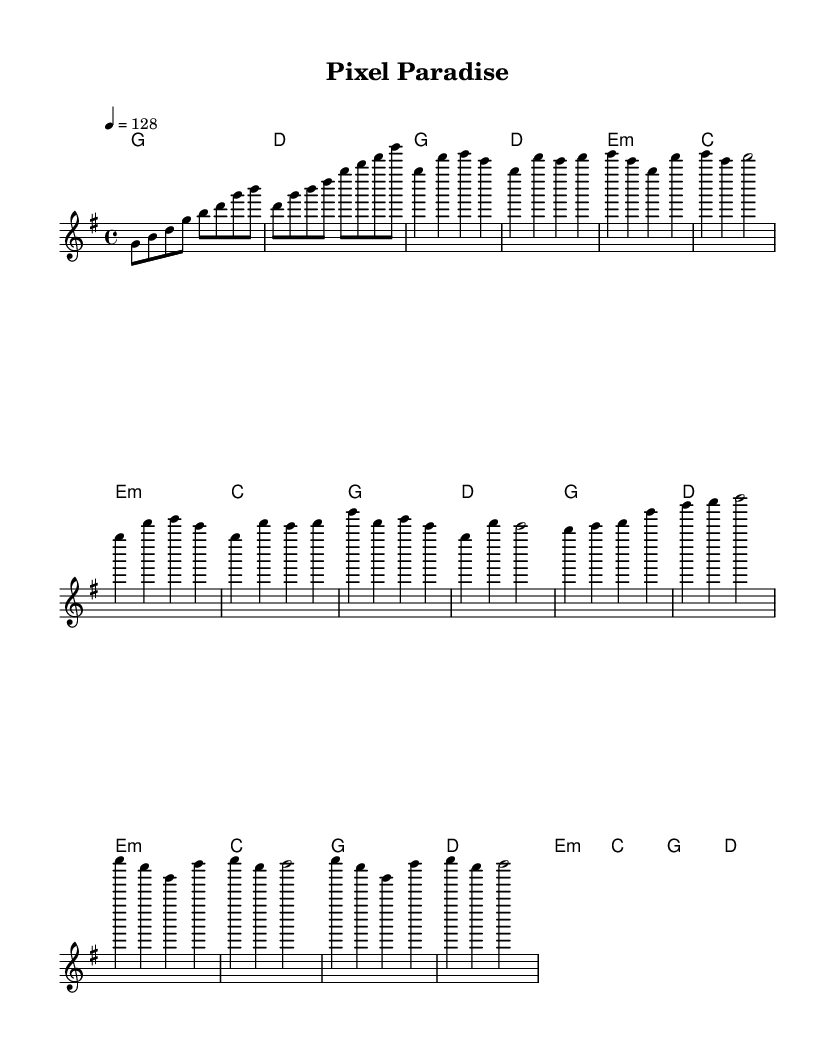What is the key signature of this music? The key signature is G major, which has one sharp (F#). This can be inferred from the beginning of the music sheet where the key signature is indicated.
Answer: G major What is the time signature of the piece? The time signature is 4/4, which is shown at the beginning of the music. This indicates that there are four beats in each measure and the quarter note receives one beat.
Answer: 4/4 What is the tempo marking of the piece? The tempo marking is 128 beats per minute, which is specified at the start of the music. This tempo is indicated by a number next to "tempo" symbol in the sheet music.
Answer: 128 How many measures are in the verse section? The verse consists of 4 measures, as indicated when looking at the melody line where the verse begins and ends. This can be counted visually in the music sheet.
Answer: 4 What type of chords are used in the Pre-Chorus? The Pre-Chorus uses E minor, C major, G major, and D major chords, as denoted in the harmonies section. These chords are shown above the melody line where the Pre-Chorus occurs.
Answer: E minor, C, G, D What is the note that starts the chorus section? The chorus starts on the note G, which can be seen as the first note of the melody section labeled "Chorus." This note serves as the foundation for the chorus part.
Answer: G In which section does the bridge occur? The bridge occurs after the post-chorus section; it can be identified by looking for the labeled sections in the melody line. The music sheet clearly separates the bridge after the post-chorus.
Answer: Bridge 